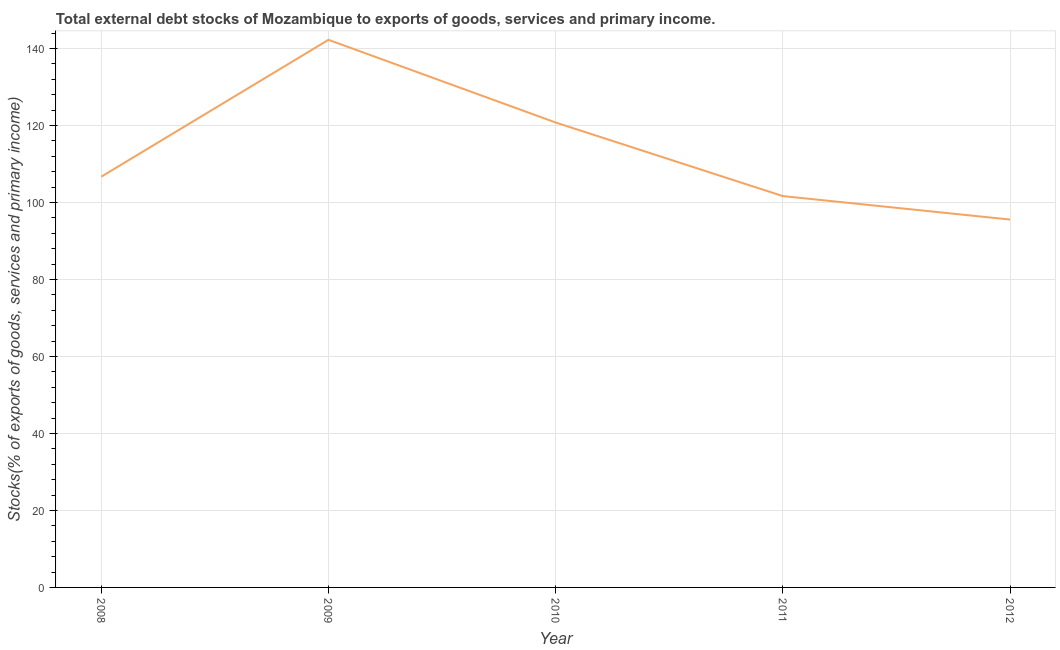What is the external debt stocks in 2012?
Your answer should be compact. 95.56. Across all years, what is the maximum external debt stocks?
Provide a succinct answer. 142.25. Across all years, what is the minimum external debt stocks?
Your answer should be compact. 95.56. In which year was the external debt stocks maximum?
Offer a terse response. 2009. In which year was the external debt stocks minimum?
Your answer should be very brief. 2012. What is the sum of the external debt stocks?
Offer a very short reply. 566.95. What is the difference between the external debt stocks in 2008 and 2010?
Give a very brief answer. -14.07. What is the average external debt stocks per year?
Offer a very short reply. 113.39. What is the median external debt stocks?
Your response must be concise. 106.7. In how many years, is the external debt stocks greater than 16 %?
Your answer should be very brief. 5. Do a majority of the years between 2009 and 2010 (inclusive) have external debt stocks greater than 68 %?
Your answer should be very brief. Yes. What is the ratio of the external debt stocks in 2008 to that in 2012?
Your answer should be very brief. 1.12. Is the difference between the external debt stocks in 2009 and 2010 greater than the difference between any two years?
Provide a short and direct response. No. What is the difference between the highest and the second highest external debt stocks?
Offer a very short reply. 21.48. Is the sum of the external debt stocks in 2008 and 2011 greater than the maximum external debt stocks across all years?
Your answer should be compact. Yes. What is the difference between the highest and the lowest external debt stocks?
Ensure brevity in your answer.  46.69. In how many years, is the external debt stocks greater than the average external debt stocks taken over all years?
Provide a short and direct response. 2. Does the external debt stocks monotonically increase over the years?
Offer a terse response. No. Are the values on the major ticks of Y-axis written in scientific E-notation?
Make the answer very short. No. What is the title of the graph?
Offer a very short reply. Total external debt stocks of Mozambique to exports of goods, services and primary income. What is the label or title of the X-axis?
Your answer should be compact. Year. What is the label or title of the Y-axis?
Offer a terse response. Stocks(% of exports of goods, services and primary income). What is the Stocks(% of exports of goods, services and primary income) of 2008?
Your answer should be compact. 106.7. What is the Stocks(% of exports of goods, services and primary income) of 2009?
Your response must be concise. 142.25. What is the Stocks(% of exports of goods, services and primary income) of 2010?
Keep it short and to the point. 120.77. What is the Stocks(% of exports of goods, services and primary income) in 2011?
Provide a succinct answer. 101.66. What is the Stocks(% of exports of goods, services and primary income) in 2012?
Offer a terse response. 95.56. What is the difference between the Stocks(% of exports of goods, services and primary income) in 2008 and 2009?
Offer a terse response. -35.55. What is the difference between the Stocks(% of exports of goods, services and primary income) in 2008 and 2010?
Offer a very short reply. -14.07. What is the difference between the Stocks(% of exports of goods, services and primary income) in 2008 and 2011?
Ensure brevity in your answer.  5.04. What is the difference between the Stocks(% of exports of goods, services and primary income) in 2008 and 2012?
Provide a succinct answer. 11.14. What is the difference between the Stocks(% of exports of goods, services and primary income) in 2009 and 2010?
Your answer should be compact. 21.48. What is the difference between the Stocks(% of exports of goods, services and primary income) in 2009 and 2011?
Your answer should be compact. 40.6. What is the difference between the Stocks(% of exports of goods, services and primary income) in 2009 and 2012?
Your answer should be compact. 46.69. What is the difference between the Stocks(% of exports of goods, services and primary income) in 2010 and 2011?
Your answer should be compact. 19.11. What is the difference between the Stocks(% of exports of goods, services and primary income) in 2010 and 2012?
Keep it short and to the point. 25.21. What is the difference between the Stocks(% of exports of goods, services and primary income) in 2011 and 2012?
Give a very brief answer. 6.09. What is the ratio of the Stocks(% of exports of goods, services and primary income) in 2008 to that in 2009?
Offer a very short reply. 0.75. What is the ratio of the Stocks(% of exports of goods, services and primary income) in 2008 to that in 2010?
Your answer should be very brief. 0.88. What is the ratio of the Stocks(% of exports of goods, services and primary income) in 2008 to that in 2012?
Offer a terse response. 1.12. What is the ratio of the Stocks(% of exports of goods, services and primary income) in 2009 to that in 2010?
Offer a terse response. 1.18. What is the ratio of the Stocks(% of exports of goods, services and primary income) in 2009 to that in 2011?
Provide a succinct answer. 1.4. What is the ratio of the Stocks(% of exports of goods, services and primary income) in 2009 to that in 2012?
Offer a terse response. 1.49. What is the ratio of the Stocks(% of exports of goods, services and primary income) in 2010 to that in 2011?
Provide a short and direct response. 1.19. What is the ratio of the Stocks(% of exports of goods, services and primary income) in 2010 to that in 2012?
Provide a short and direct response. 1.26. What is the ratio of the Stocks(% of exports of goods, services and primary income) in 2011 to that in 2012?
Make the answer very short. 1.06. 